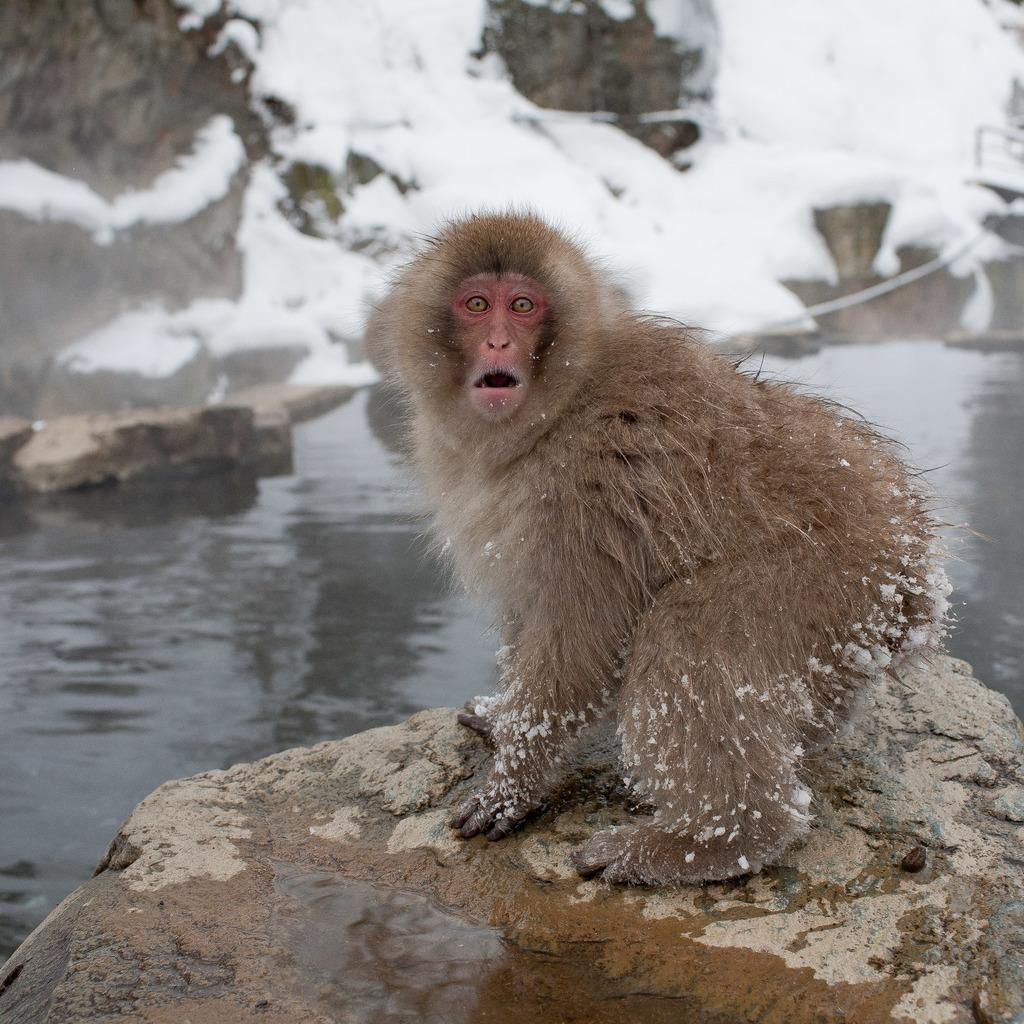What animal is present in the image? There is a monkey in the image. What is the monkey doing in the image? The monkey is looking at someone. What else can be seen in the image besides the monkey? There is water in the image. What type of force is being applied by the monkey in the image? There is no indication of any force being applied by the monkey in the image. 